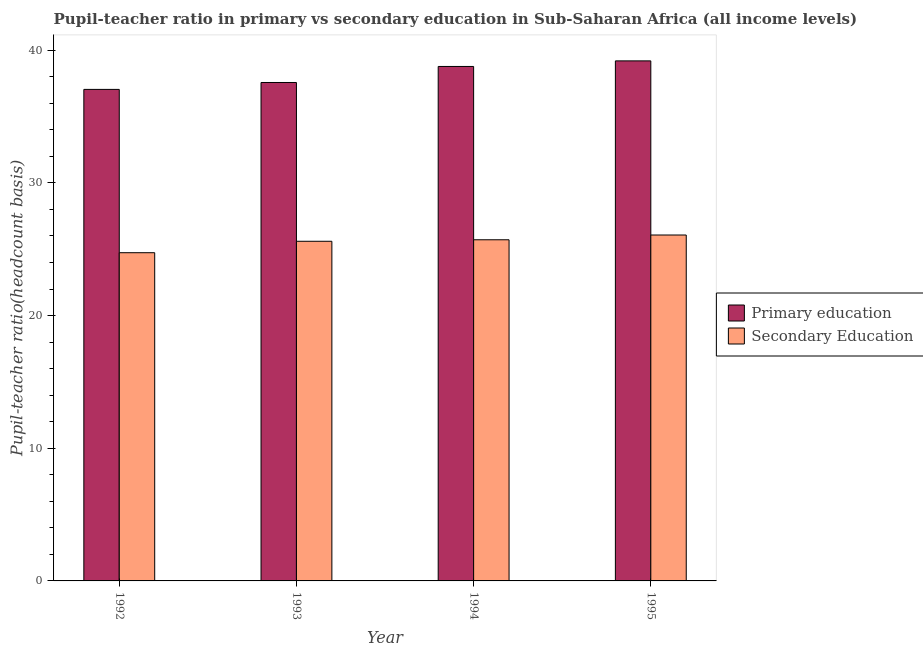Are the number of bars per tick equal to the number of legend labels?
Offer a terse response. Yes. Are the number of bars on each tick of the X-axis equal?
Make the answer very short. Yes. How many bars are there on the 1st tick from the right?
Offer a very short reply. 2. In how many cases, is the number of bars for a given year not equal to the number of legend labels?
Your answer should be compact. 0. What is the pupil-teacher ratio in primary education in 1993?
Your response must be concise. 37.57. Across all years, what is the maximum pupil teacher ratio on secondary education?
Your response must be concise. 26.07. Across all years, what is the minimum pupil teacher ratio on secondary education?
Provide a short and direct response. 24.74. In which year was the pupil teacher ratio on secondary education maximum?
Offer a very short reply. 1995. What is the total pupil-teacher ratio in primary education in the graph?
Give a very brief answer. 152.58. What is the difference between the pupil teacher ratio on secondary education in 1992 and that in 1995?
Your answer should be compact. -1.33. What is the difference between the pupil teacher ratio on secondary education in 1994 and the pupil-teacher ratio in primary education in 1993?
Offer a very short reply. 0.11. What is the average pupil teacher ratio on secondary education per year?
Provide a succinct answer. 25.53. In the year 1994, what is the difference between the pupil-teacher ratio in primary education and pupil teacher ratio on secondary education?
Keep it short and to the point. 0. What is the ratio of the pupil-teacher ratio in primary education in 1993 to that in 1994?
Your answer should be very brief. 0.97. Is the pupil-teacher ratio in primary education in 1993 less than that in 1995?
Give a very brief answer. Yes. What is the difference between the highest and the second highest pupil-teacher ratio in primary education?
Offer a very short reply. 0.42. What is the difference between the highest and the lowest pupil-teacher ratio in primary education?
Offer a very short reply. 2.15. In how many years, is the pupil teacher ratio on secondary education greater than the average pupil teacher ratio on secondary education taken over all years?
Offer a very short reply. 3. Is the sum of the pupil-teacher ratio in primary education in 1992 and 1993 greater than the maximum pupil teacher ratio on secondary education across all years?
Provide a succinct answer. Yes. Are all the bars in the graph horizontal?
Ensure brevity in your answer.  No. Are the values on the major ticks of Y-axis written in scientific E-notation?
Offer a terse response. No. Does the graph contain any zero values?
Provide a succinct answer. No. Where does the legend appear in the graph?
Ensure brevity in your answer.  Center right. How are the legend labels stacked?
Keep it short and to the point. Vertical. What is the title of the graph?
Provide a short and direct response. Pupil-teacher ratio in primary vs secondary education in Sub-Saharan Africa (all income levels). Does "Taxes" appear as one of the legend labels in the graph?
Offer a very short reply. No. What is the label or title of the Y-axis?
Offer a terse response. Pupil-teacher ratio(headcount basis). What is the Pupil-teacher ratio(headcount basis) of Primary education in 1992?
Your answer should be very brief. 37.05. What is the Pupil-teacher ratio(headcount basis) in Secondary Education in 1992?
Offer a terse response. 24.74. What is the Pupil-teacher ratio(headcount basis) in Primary education in 1993?
Provide a short and direct response. 37.57. What is the Pupil-teacher ratio(headcount basis) of Secondary Education in 1993?
Your answer should be very brief. 25.6. What is the Pupil-teacher ratio(headcount basis) of Primary education in 1994?
Give a very brief answer. 38.77. What is the Pupil-teacher ratio(headcount basis) of Secondary Education in 1994?
Make the answer very short. 25.71. What is the Pupil-teacher ratio(headcount basis) in Primary education in 1995?
Ensure brevity in your answer.  39.19. What is the Pupil-teacher ratio(headcount basis) in Secondary Education in 1995?
Provide a short and direct response. 26.07. Across all years, what is the maximum Pupil-teacher ratio(headcount basis) in Primary education?
Keep it short and to the point. 39.19. Across all years, what is the maximum Pupil-teacher ratio(headcount basis) of Secondary Education?
Offer a very short reply. 26.07. Across all years, what is the minimum Pupil-teacher ratio(headcount basis) of Primary education?
Your answer should be very brief. 37.05. Across all years, what is the minimum Pupil-teacher ratio(headcount basis) of Secondary Education?
Give a very brief answer. 24.74. What is the total Pupil-teacher ratio(headcount basis) of Primary education in the graph?
Your answer should be very brief. 152.58. What is the total Pupil-teacher ratio(headcount basis) in Secondary Education in the graph?
Your answer should be compact. 102.12. What is the difference between the Pupil-teacher ratio(headcount basis) in Primary education in 1992 and that in 1993?
Offer a very short reply. -0.52. What is the difference between the Pupil-teacher ratio(headcount basis) in Secondary Education in 1992 and that in 1993?
Make the answer very short. -0.86. What is the difference between the Pupil-teacher ratio(headcount basis) of Primary education in 1992 and that in 1994?
Offer a very short reply. -1.73. What is the difference between the Pupil-teacher ratio(headcount basis) in Secondary Education in 1992 and that in 1994?
Your response must be concise. -0.98. What is the difference between the Pupil-teacher ratio(headcount basis) of Primary education in 1992 and that in 1995?
Offer a terse response. -2.15. What is the difference between the Pupil-teacher ratio(headcount basis) in Secondary Education in 1992 and that in 1995?
Keep it short and to the point. -1.33. What is the difference between the Pupil-teacher ratio(headcount basis) in Primary education in 1993 and that in 1994?
Give a very brief answer. -1.21. What is the difference between the Pupil-teacher ratio(headcount basis) in Secondary Education in 1993 and that in 1994?
Your response must be concise. -0.11. What is the difference between the Pupil-teacher ratio(headcount basis) of Primary education in 1993 and that in 1995?
Keep it short and to the point. -1.63. What is the difference between the Pupil-teacher ratio(headcount basis) of Secondary Education in 1993 and that in 1995?
Make the answer very short. -0.47. What is the difference between the Pupil-teacher ratio(headcount basis) in Primary education in 1994 and that in 1995?
Ensure brevity in your answer.  -0.42. What is the difference between the Pupil-teacher ratio(headcount basis) in Secondary Education in 1994 and that in 1995?
Your answer should be compact. -0.36. What is the difference between the Pupil-teacher ratio(headcount basis) of Primary education in 1992 and the Pupil-teacher ratio(headcount basis) of Secondary Education in 1993?
Make the answer very short. 11.45. What is the difference between the Pupil-teacher ratio(headcount basis) in Primary education in 1992 and the Pupil-teacher ratio(headcount basis) in Secondary Education in 1994?
Your response must be concise. 11.33. What is the difference between the Pupil-teacher ratio(headcount basis) of Primary education in 1992 and the Pupil-teacher ratio(headcount basis) of Secondary Education in 1995?
Provide a short and direct response. 10.98. What is the difference between the Pupil-teacher ratio(headcount basis) in Primary education in 1993 and the Pupil-teacher ratio(headcount basis) in Secondary Education in 1994?
Your response must be concise. 11.85. What is the difference between the Pupil-teacher ratio(headcount basis) in Primary education in 1993 and the Pupil-teacher ratio(headcount basis) in Secondary Education in 1995?
Make the answer very short. 11.49. What is the difference between the Pupil-teacher ratio(headcount basis) in Primary education in 1994 and the Pupil-teacher ratio(headcount basis) in Secondary Education in 1995?
Offer a very short reply. 12.7. What is the average Pupil-teacher ratio(headcount basis) of Primary education per year?
Provide a short and direct response. 38.14. What is the average Pupil-teacher ratio(headcount basis) of Secondary Education per year?
Offer a terse response. 25.53. In the year 1992, what is the difference between the Pupil-teacher ratio(headcount basis) in Primary education and Pupil-teacher ratio(headcount basis) in Secondary Education?
Your answer should be compact. 12.31. In the year 1993, what is the difference between the Pupil-teacher ratio(headcount basis) in Primary education and Pupil-teacher ratio(headcount basis) in Secondary Education?
Your response must be concise. 11.97. In the year 1994, what is the difference between the Pupil-teacher ratio(headcount basis) in Primary education and Pupil-teacher ratio(headcount basis) in Secondary Education?
Your response must be concise. 13.06. In the year 1995, what is the difference between the Pupil-teacher ratio(headcount basis) of Primary education and Pupil-teacher ratio(headcount basis) of Secondary Education?
Your answer should be compact. 13.12. What is the ratio of the Pupil-teacher ratio(headcount basis) of Primary education in 1992 to that in 1993?
Ensure brevity in your answer.  0.99. What is the ratio of the Pupil-teacher ratio(headcount basis) of Secondary Education in 1992 to that in 1993?
Offer a very short reply. 0.97. What is the ratio of the Pupil-teacher ratio(headcount basis) of Primary education in 1992 to that in 1994?
Your response must be concise. 0.96. What is the ratio of the Pupil-teacher ratio(headcount basis) in Secondary Education in 1992 to that in 1994?
Your answer should be compact. 0.96. What is the ratio of the Pupil-teacher ratio(headcount basis) of Primary education in 1992 to that in 1995?
Make the answer very short. 0.95. What is the ratio of the Pupil-teacher ratio(headcount basis) of Secondary Education in 1992 to that in 1995?
Give a very brief answer. 0.95. What is the ratio of the Pupil-teacher ratio(headcount basis) in Primary education in 1993 to that in 1994?
Keep it short and to the point. 0.97. What is the ratio of the Pupil-teacher ratio(headcount basis) of Secondary Education in 1993 to that in 1994?
Your response must be concise. 1. What is the ratio of the Pupil-teacher ratio(headcount basis) in Primary education in 1993 to that in 1995?
Your response must be concise. 0.96. What is the ratio of the Pupil-teacher ratio(headcount basis) of Secondary Education in 1993 to that in 1995?
Keep it short and to the point. 0.98. What is the ratio of the Pupil-teacher ratio(headcount basis) of Primary education in 1994 to that in 1995?
Offer a very short reply. 0.99. What is the ratio of the Pupil-teacher ratio(headcount basis) in Secondary Education in 1994 to that in 1995?
Provide a short and direct response. 0.99. What is the difference between the highest and the second highest Pupil-teacher ratio(headcount basis) of Primary education?
Provide a succinct answer. 0.42. What is the difference between the highest and the second highest Pupil-teacher ratio(headcount basis) in Secondary Education?
Make the answer very short. 0.36. What is the difference between the highest and the lowest Pupil-teacher ratio(headcount basis) of Primary education?
Keep it short and to the point. 2.15. What is the difference between the highest and the lowest Pupil-teacher ratio(headcount basis) in Secondary Education?
Keep it short and to the point. 1.33. 